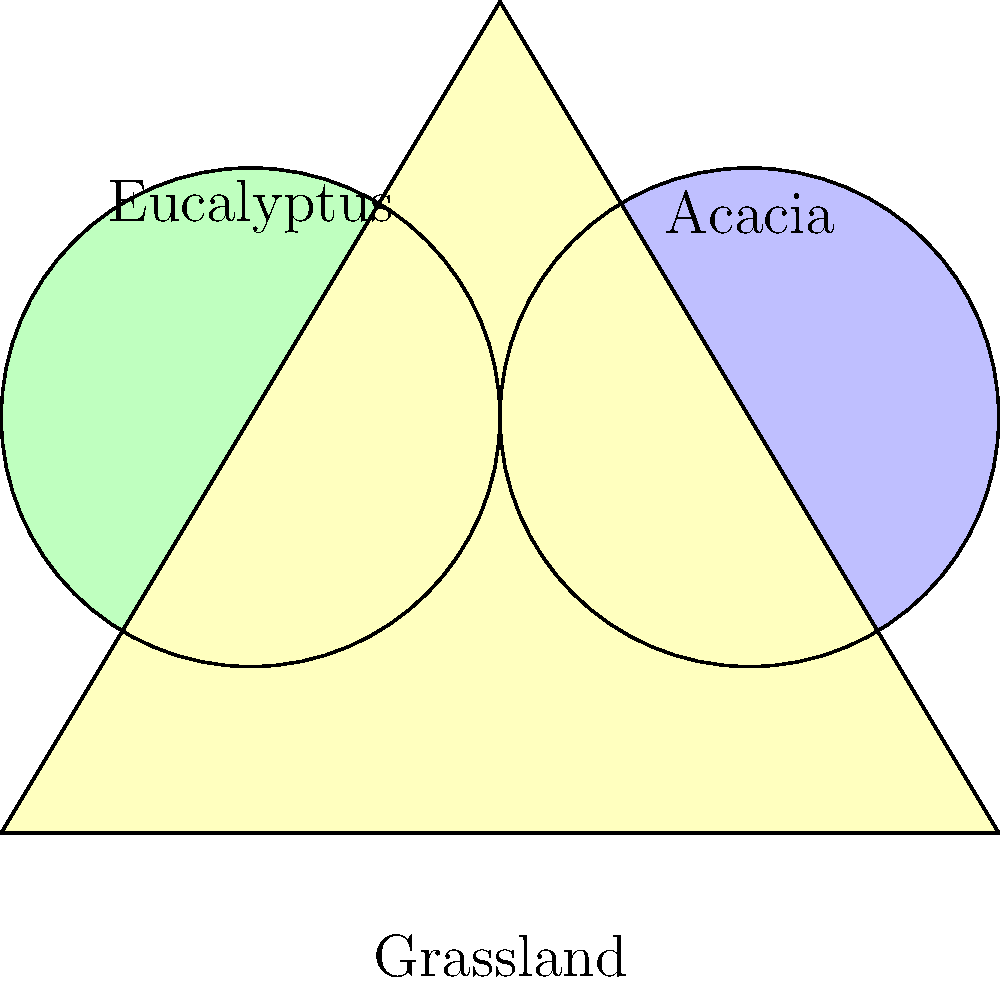In a national park, you're estimating vegetation coverage using geometric shapes. A triangular grassland area is overlapped by circular regions of Eucalyptus and Acacia trees. The grassland triangle has a base of 6 km and a height of 5 km. Each circular tree region has a radius of 1.5 km. What percentage of the grassland area is covered by at least one type of tree vegetation? Let's approach this step-by-step:

1) First, calculate the area of the grassland triangle:
   $$A_{triangle} = \frac{1}{2} \times base \times height = \frac{1}{2} \times 6 \times 5 = 15 \text{ km}^2$$

2) Calculate the area of each circular tree region:
   $$A_{circle} = \pi r^2 = \pi \times 1.5^2 \approx 7.0686 \text{ km}^2$$

3) The circles overlap. We need to find the area of this overlap. The distance between circle centers is 3 km (half the base of the triangle). Using the formula for the area of intersection of two circles:
   $$A_{overlap} = 2r^2 \arccos(\frac{d}{2r}) - d\sqrt{r^2 - \frac{d^2}{4}}$$
   Where $r = 1.5$ and $d = 3$
   $$A_{overlap} \approx 0.9098 \text{ km}^2$$

4) The total area covered by trees is:
   $$A_{trees} = 2A_{circle} - A_{overlap} \approx 2 \times 7.0686 - 0.9098 = 13.2274 \text{ km}^2$$

5) However, some of this area falls outside the triangle. We can approximate that about 3/4 of each circle is within the triangle:
   $$A_{trees in triangle} \approx \frac{3}{4} \times 13.2274 = 9.9206 \text{ km}^2$$

6) Calculate the percentage:
   $$Percentage = \frac{A_{trees in triangle}}{A_{triangle}} \times 100\% = \frac{9.9206}{15} \times 100\% \approx 66.14\%$$
Answer: Approximately 66.14% of the grassland area is covered by trees. 